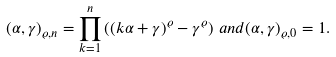<formula> <loc_0><loc_0><loc_500><loc_500>( \alpha , \gamma ) _ { \varrho , n } = \prod _ { k = 1 } ^ { n } \left ( ( k \alpha + \gamma ) ^ { \varrho } - \gamma ^ { \varrho } \right ) \, a n d ( \alpha , \gamma ) _ { \varrho , 0 } = 1 .</formula> 